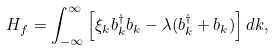<formula> <loc_0><loc_0><loc_500><loc_500>H _ { f } = \int _ { - \infty } ^ { \infty } \left [ \xi _ { k } b _ { k } ^ { \dagger } b _ { k } - \lambda ( b _ { k } ^ { \dagger } + b _ { k } ) \right ] d k ,</formula> 